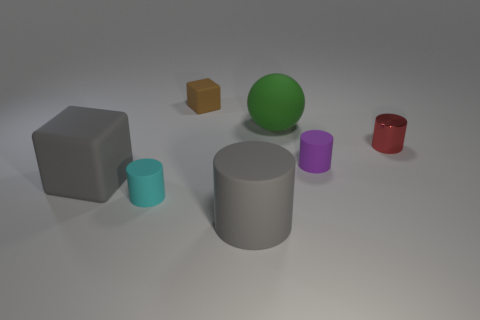Subtract all small red shiny cylinders. How many cylinders are left? 3 Add 1 large blue objects. How many objects exist? 8 Subtract all red cylinders. How many cylinders are left? 3 Subtract all blocks. How many objects are left? 5 Subtract all purple cylinders. How many gray blocks are left? 1 Subtract all tiny brown shiny objects. Subtract all green rubber balls. How many objects are left? 6 Add 1 brown things. How many brown things are left? 2 Add 4 shiny things. How many shiny things exist? 5 Subtract 1 brown cubes. How many objects are left? 6 Subtract 1 spheres. How many spheres are left? 0 